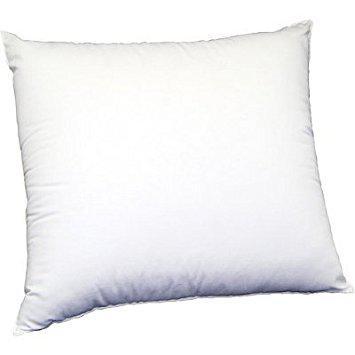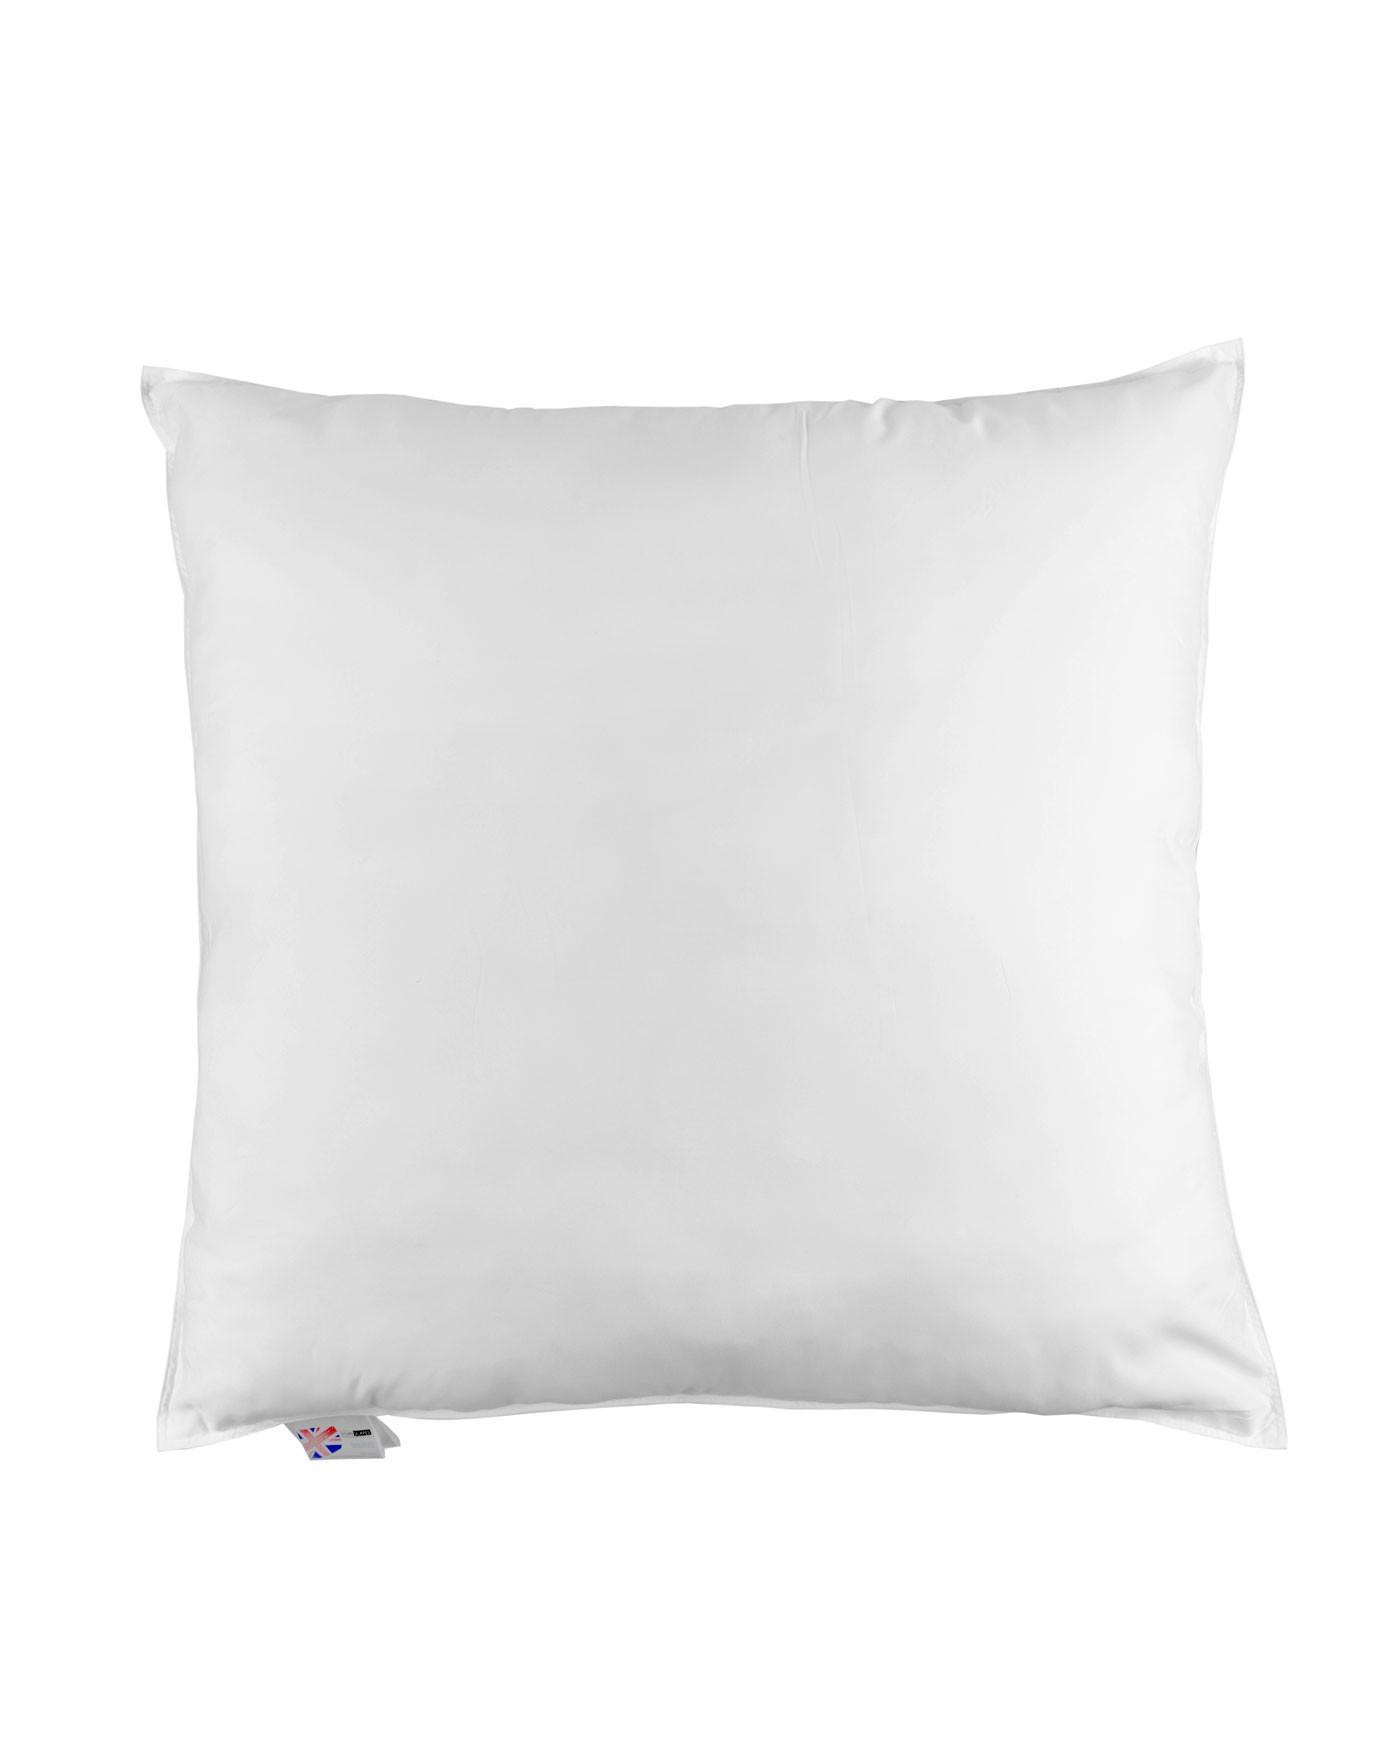The first image is the image on the left, the second image is the image on the right. Examine the images to the left and right. Is the description "One image shows a single white rectangular pillow, and the other image shows a square upright pillow overlapping a pillow on its side." accurate? Answer yes or no. No. The first image is the image on the left, the second image is the image on the right. Examine the images to the left and right. Is the description "Two pillows are visible in the left image, while there is just one pillow on the right" accurate? Answer yes or no. No. 